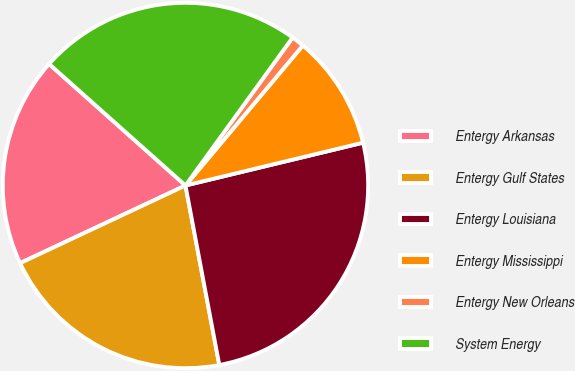Convert chart to OTSL. <chart><loc_0><loc_0><loc_500><loc_500><pie_chart><fcel>Entergy Arkansas<fcel>Entergy Gulf States<fcel>Entergy Louisiana<fcel>Entergy Mississippi<fcel>Entergy New Orleans<fcel>System Energy<nl><fcel>18.57%<fcel>20.98%<fcel>25.8%<fcel>10.13%<fcel>1.13%<fcel>23.39%<nl></chart> 